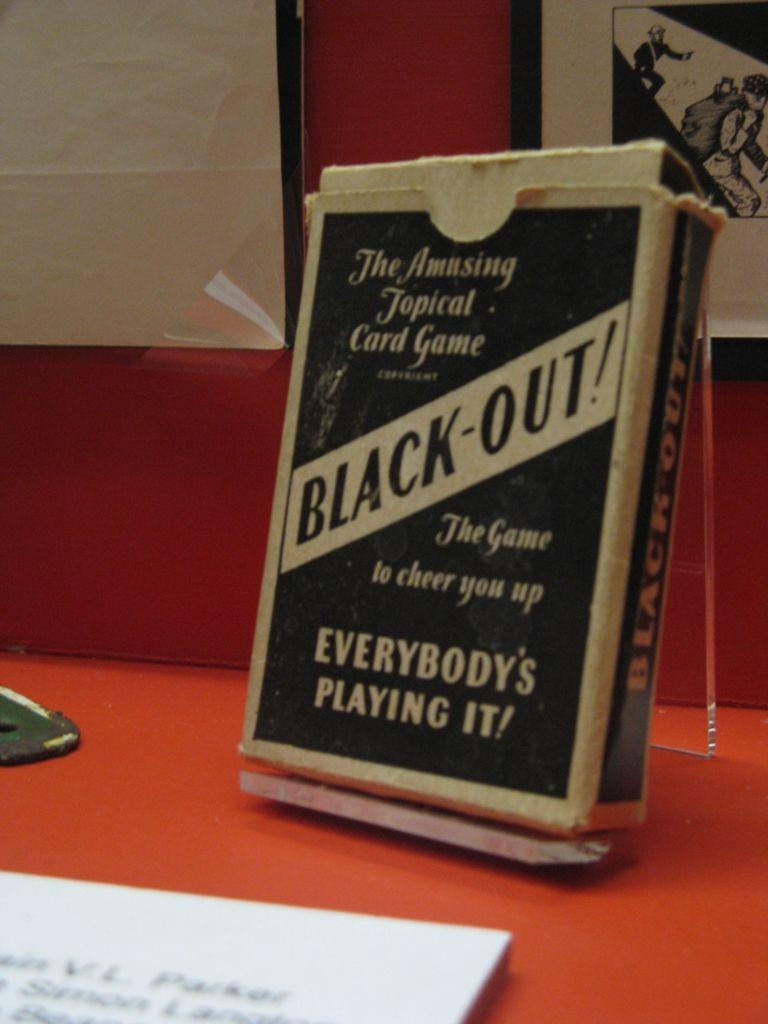<image>
Give a short and clear explanation of the subsequent image. A beat up card box contains the game Black Out. 